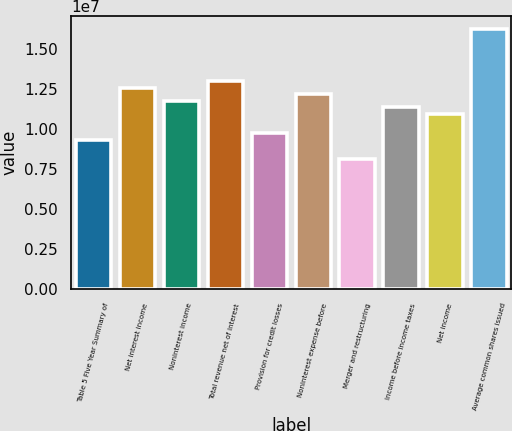Convert chart. <chart><loc_0><loc_0><loc_500><loc_500><bar_chart><fcel>Table 5 Five Year Summary of<fcel>Net interest income<fcel>Noninterest income<fcel>Total revenue net of interest<fcel>Provision for credit losses<fcel>Noninterest expense before<fcel>Merger and restructuring<fcel>Income before income taxes<fcel>Net income<fcel>Average common shares issued<nl><fcel>9.35672e+06<fcel>1.26112e+07<fcel>1.17976e+07<fcel>1.3018e+07<fcel>9.76354e+06<fcel>1.22044e+07<fcel>8.13628e+06<fcel>1.13908e+07<fcel>1.0984e+07<fcel>1.62726e+07<nl></chart> 